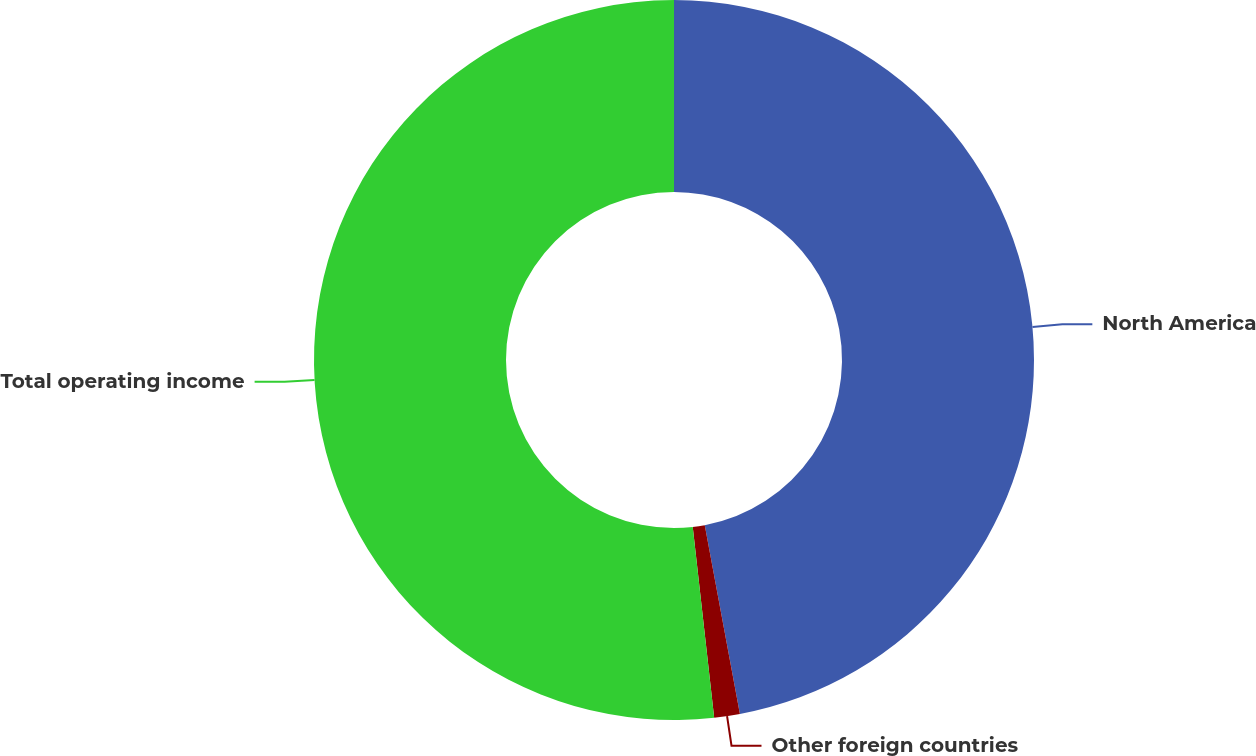Convert chart to OTSL. <chart><loc_0><loc_0><loc_500><loc_500><pie_chart><fcel>North America<fcel>Other foreign countries<fcel>Total operating income<nl><fcel>47.07%<fcel>1.15%<fcel>51.78%<nl></chart> 